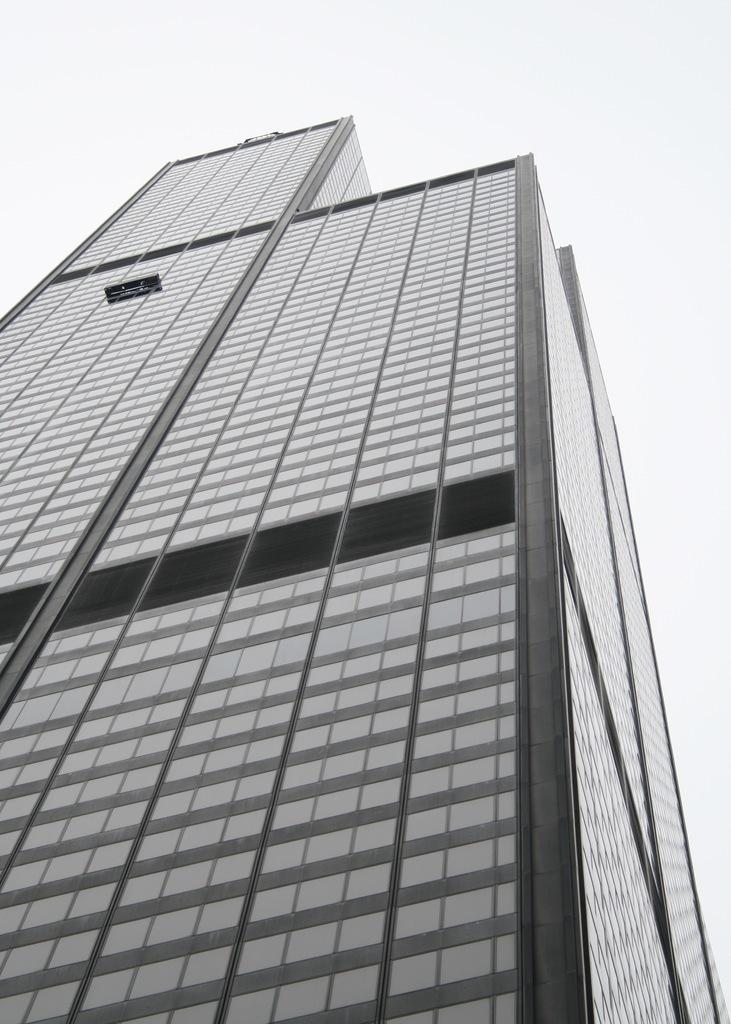Where was the image likely taken from? The image was likely taken from outside of a building. What can be seen in the image? There is a building in the image. What color is visible in the background of the image? There is a white color visible in the background of the image. How many apples are on the wooden table in the image? There are no apples or wooden table present in the image. 